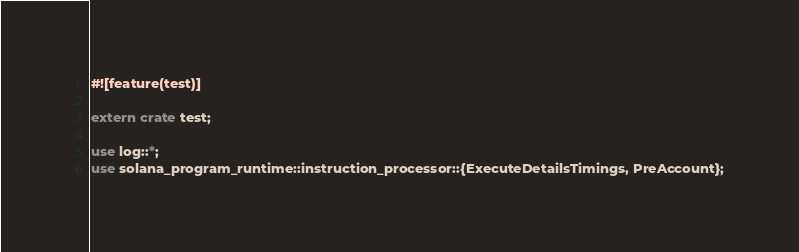Convert code to text. <code><loc_0><loc_0><loc_500><loc_500><_Rust_>#![feature(test)]

extern crate test;

use log::*;
use solana_program_runtime::instruction_processor::{ExecuteDetailsTimings, PreAccount};</code> 